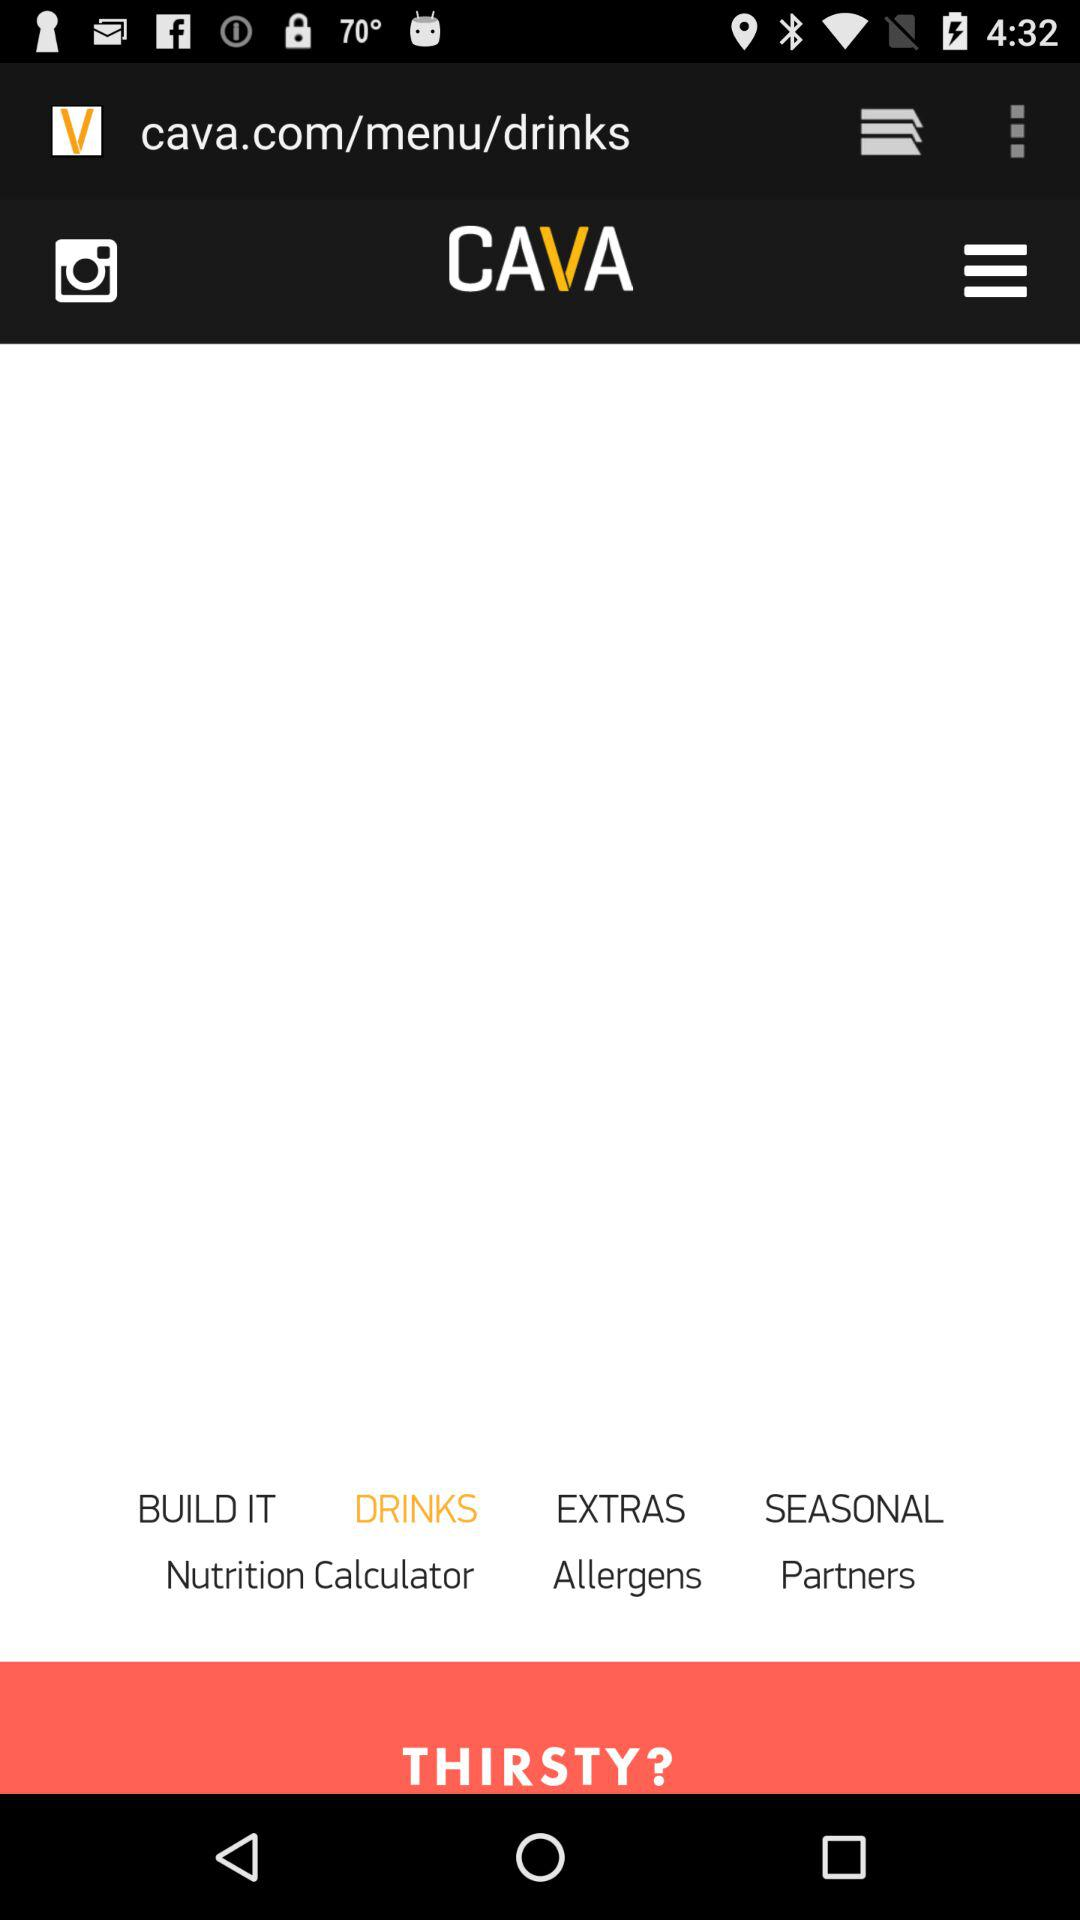What is the application name? The application name is CAVA. 